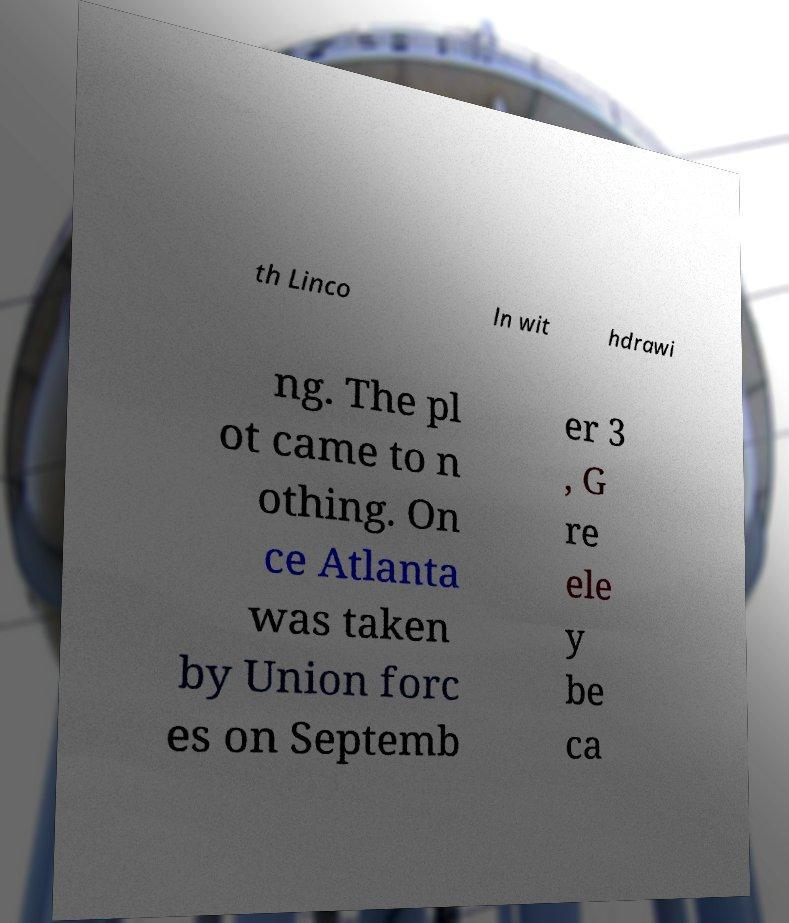Can you accurately transcribe the text from the provided image for me? th Linco ln wit hdrawi ng. The pl ot came to n othing. On ce Atlanta was taken by Union forc es on Septemb er 3 , G re ele y be ca 